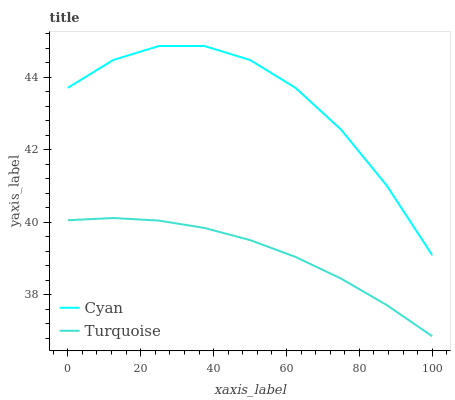Does Turquoise have the minimum area under the curve?
Answer yes or no. Yes. Does Cyan have the maximum area under the curve?
Answer yes or no. Yes. Does Turquoise have the maximum area under the curve?
Answer yes or no. No. Is Turquoise the smoothest?
Answer yes or no. Yes. Is Cyan the roughest?
Answer yes or no. Yes. Is Turquoise the roughest?
Answer yes or no. No. Does Turquoise have the lowest value?
Answer yes or no. Yes. Does Cyan have the highest value?
Answer yes or no. Yes. Does Turquoise have the highest value?
Answer yes or no. No. Is Turquoise less than Cyan?
Answer yes or no. Yes. Is Cyan greater than Turquoise?
Answer yes or no. Yes. Does Turquoise intersect Cyan?
Answer yes or no. No. 